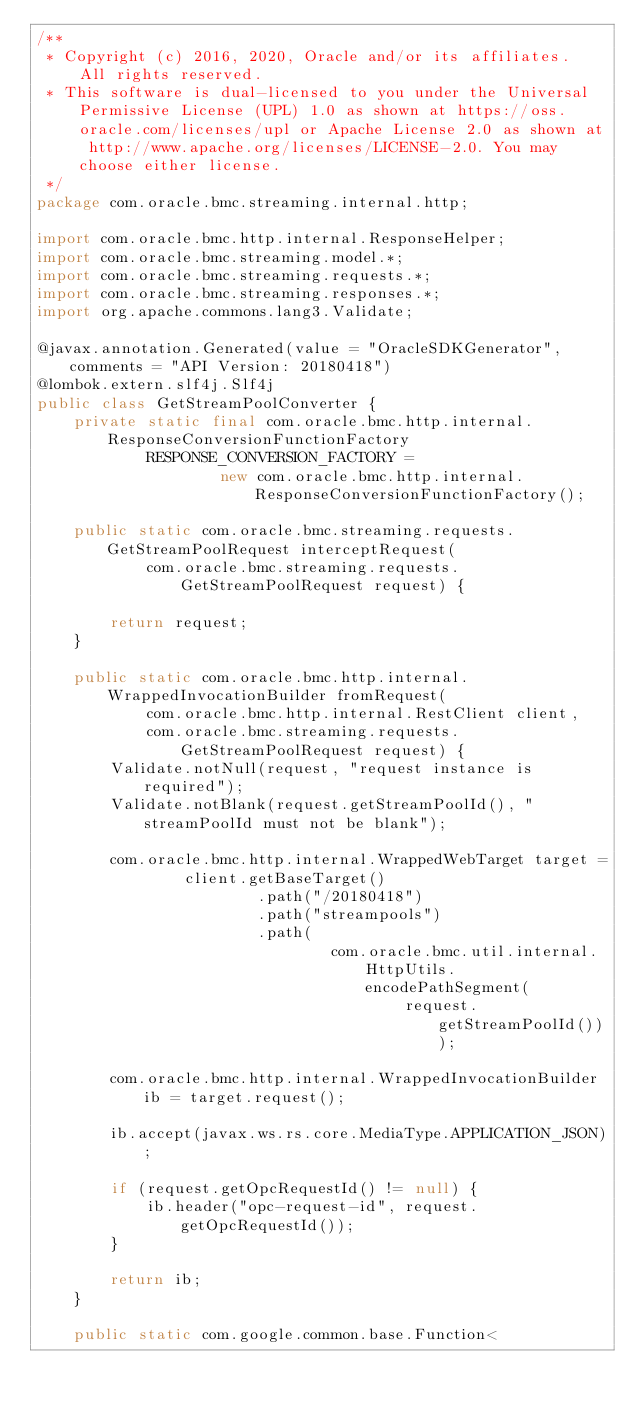<code> <loc_0><loc_0><loc_500><loc_500><_Java_>/**
 * Copyright (c) 2016, 2020, Oracle and/or its affiliates.  All rights reserved.
 * This software is dual-licensed to you under the Universal Permissive License (UPL) 1.0 as shown at https://oss.oracle.com/licenses/upl or Apache License 2.0 as shown at http://www.apache.org/licenses/LICENSE-2.0. You may choose either license.
 */
package com.oracle.bmc.streaming.internal.http;

import com.oracle.bmc.http.internal.ResponseHelper;
import com.oracle.bmc.streaming.model.*;
import com.oracle.bmc.streaming.requests.*;
import com.oracle.bmc.streaming.responses.*;
import org.apache.commons.lang3.Validate;

@javax.annotation.Generated(value = "OracleSDKGenerator", comments = "API Version: 20180418")
@lombok.extern.slf4j.Slf4j
public class GetStreamPoolConverter {
    private static final com.oracle.bmc.http.internal.ResponseConversionFunctionFactory
            RESPONSE_CONVERSION_FACTORY =
                    new com.oracle.bmc.http.internal.ResponseConversionFunctionFactory();

    public static com.oracle.bmc.streaming.requests.GetStreamPoolRequest interceptRequest(
            com.oracle.bmc.streaming.requests.GetStreamPoolRequest request) {

        return request;
    }

    public static com.oracle.bmc.http.internal.WrappedInvocationBuilder fromRequest(
            com.oracle.bmc.http.internal.RestClient client,
            com.oracle.bmc.streaming.requests.GetStreamPoolRequest request) {
        Validate.notNull(request, "request instance is required");
        Validate.notBlank(request.getStreamPoolId(), "streamPoolId must not be blank");

        com.oracle.bmc.http.internal.WrappedWebTarget target =
                client.getBaseTarget()
                        .path("/20180418")
                        .path("streampools")
                        .path(
                                com.oracle.bmc.util.internal.HttpUtils.encodePathSegment(
                                        request.getStreamPoolId()));

        com.oracle.bmc.http.internal.WrappedInvocationBuilder ib = target.request();

        ib.accept(javax.ws.rs.core.MediaType.APPLICATION_JSON);

        if (request.getOpcRequestId() != null) {
            ib.header("opc-request-id", request.getOpcRequestId());
        }

        return ib;
    }

    public static com.google.common.base.Function<</code> 